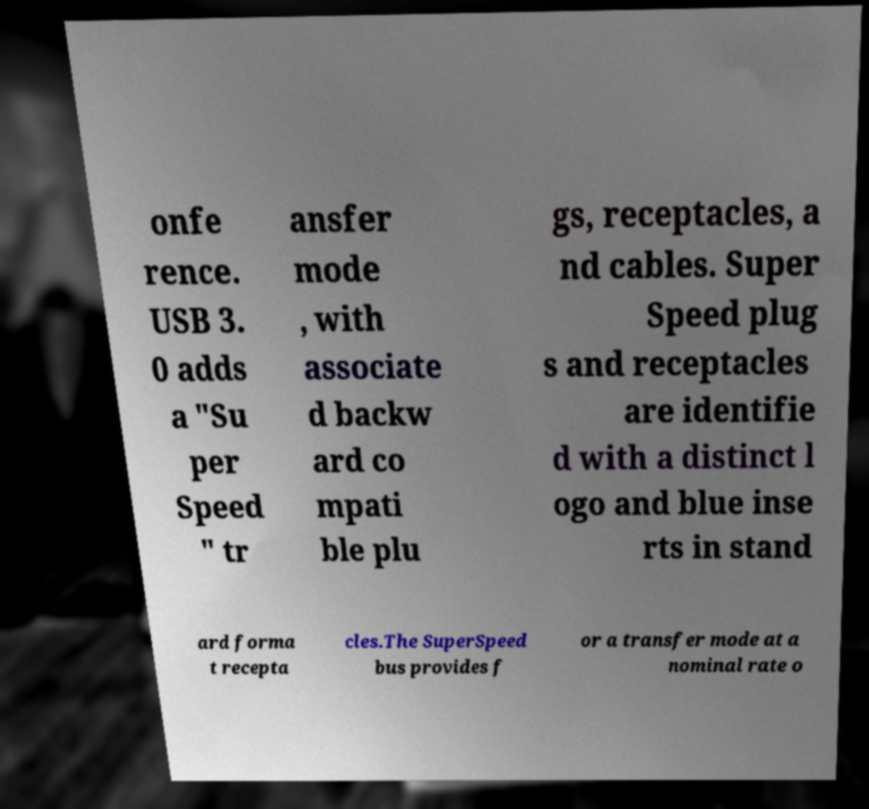Could you extract and type out the text from this image? onfe rence. USB 3. 0 adds a "Su per Speed " tr ansfer mode , with associate d backw ard co mpati ble plu gs, receptacles, a nd cables. Super Speed plug s and receptacles are identifie d with a distinct l ogo and blue inse rts in stand ard forma t recepta cles.The SuperSpeed bus provides f or a transfer mode at a nominal rate o 